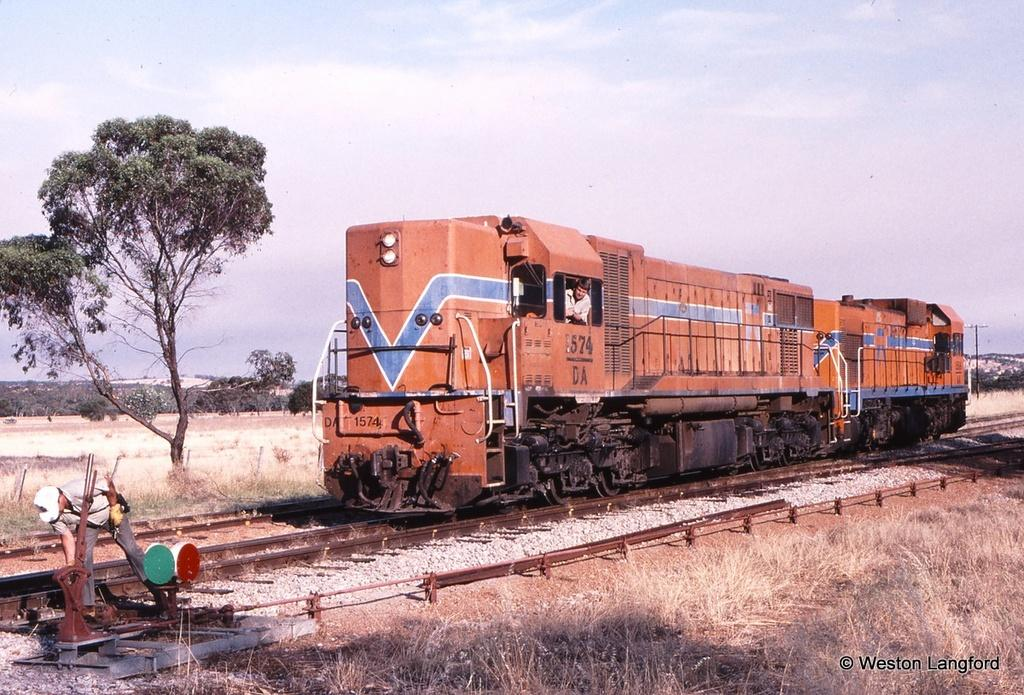What is the main subject of the image? The main subject of the image is a train on a railway track. What type of vegetation can be seen in the image? Grass and trees are present in the image. What other objects can be seen in the image? Stones, a fence, a pole, and some unspecified objects are present in the image. How many people are in the image? There are two people in the image. What is visible in the background of the image? The sky is visible in the background of the image. How many lizards are climbing on the train in the image? There are no lizards present in the image; the train is not depicted with any lizards climbing on it. 